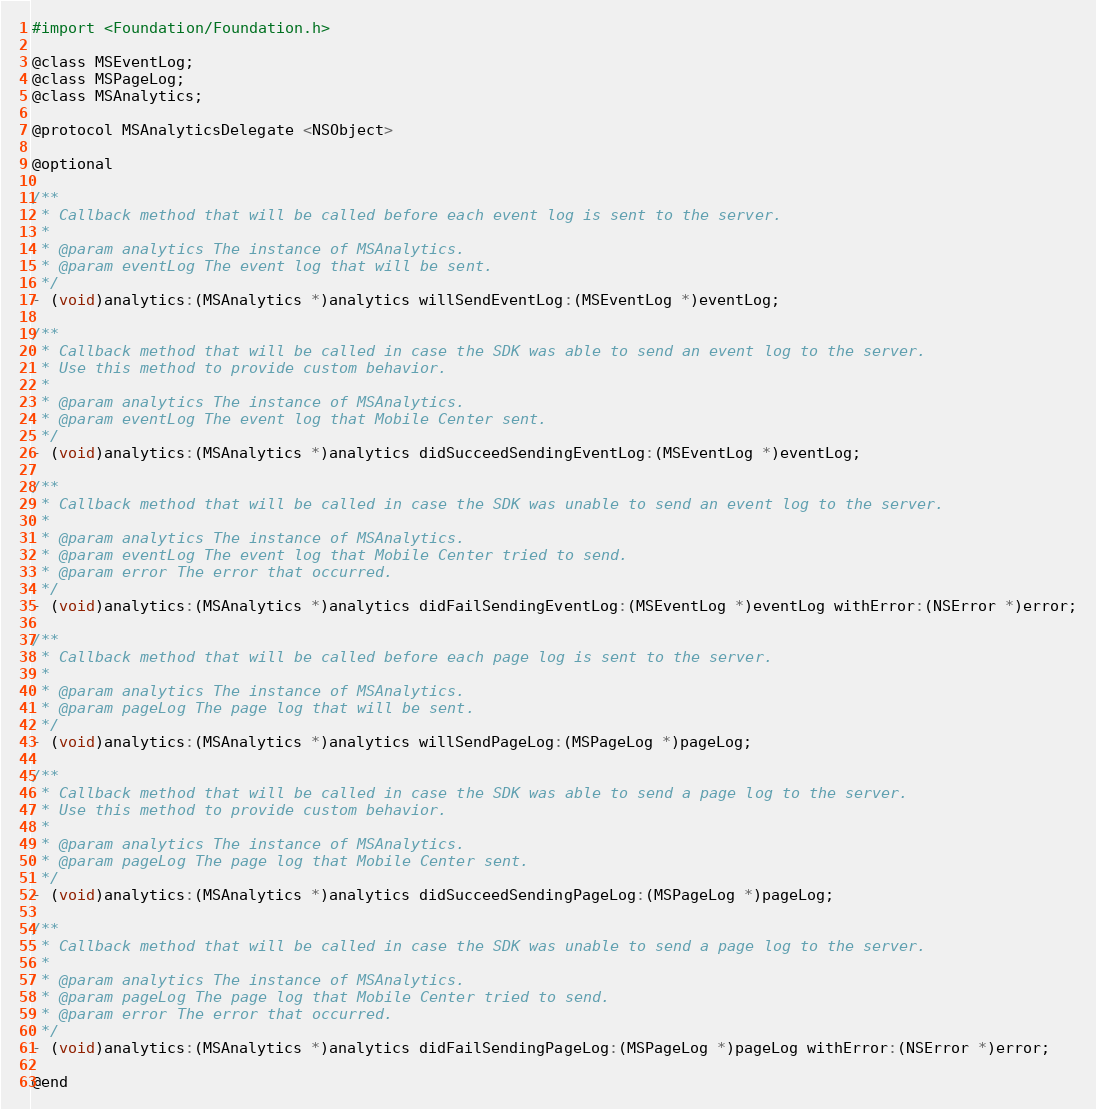Convert code to text. <code><loc_0><loc_0><loc_500><loc_500><_C_>#import <Foundation/Foundation.h>

@class MSEventLog;
@class MSPageLog;
@class MSAnalytics;

@protocol MSAnalyticsDelegate <NSObject>

@optional

/**
 * Callback method that will be called before each event log is sent to the server.
 *
 * @param analytics The instance of MSAnalytics.
 * @param eventLog The event log that will be sent.
 */
- (void)analytics:(MSAnalytics *)analytics willSendEventLog:(MSEventLog *)eventLog;

/**
 * Callback method that will be called in case the SDK was able to send an event log to the server.
 * Use this method to provide custom behavior.
 *
 * @param analytics The instance of MSAnalytics.
 * @param eventLog The event log that Mobile Center sent.
 */
- (void)analytics:(MSAnalytics *)analytics didSucceedSendingEventLog:(MSEventLog *)eventLog;

/**
 * Callback method that will be called in case the SDK was unable to send an event log to the server.
 *
 * @param analytics The instance of MSAnalytics.
 * @param eventLog The event log that Mobile Center tried to send.
 * @param error The error that occurred.
 */
- (void)analytics:(MSAnalytics *)analytics didFailSendingEventLog:(MSEventLog *)eventLog withError:(NSError *)error;

/**
 * Callback method that will be called before each page log is sent to the server.
 *
 * @param analytics The instance of MSAnalytics.
 * @param pageLog The page log that will be sent.
 */
- (void)analytics:(MSAnalytics *)analytics willSendPageLog:(MSPageLog *)pageLog;

/**
 * Callback method that will be called in case the SDK was able to send a page log to the server.
 * Use this method to provide custom behavior.
 *
 * @param analytics The instance of MSAnalytics.
 * @param pageLog The page log that Mobile Center sent.
 */
- (void)analytics:(MSAnalytics *)analytics didSucceedSendingPageLog:(MSPageLog *)pageLog;

/**
 * Callback method that will be called in case the SDK was unable to send a page log to the server.
 *
 * @param analytics The instance of MSAnalytics.
 * @param pageLog The page log that Mobile Center tried to send.
 * @param error The error that occurred.
 */
- (void)analytics:(MSAnalytics *)analytics didFailSendingPageLog:(MSPageLog *)pageLog withError:(NSError *)error;

@end
</code> 